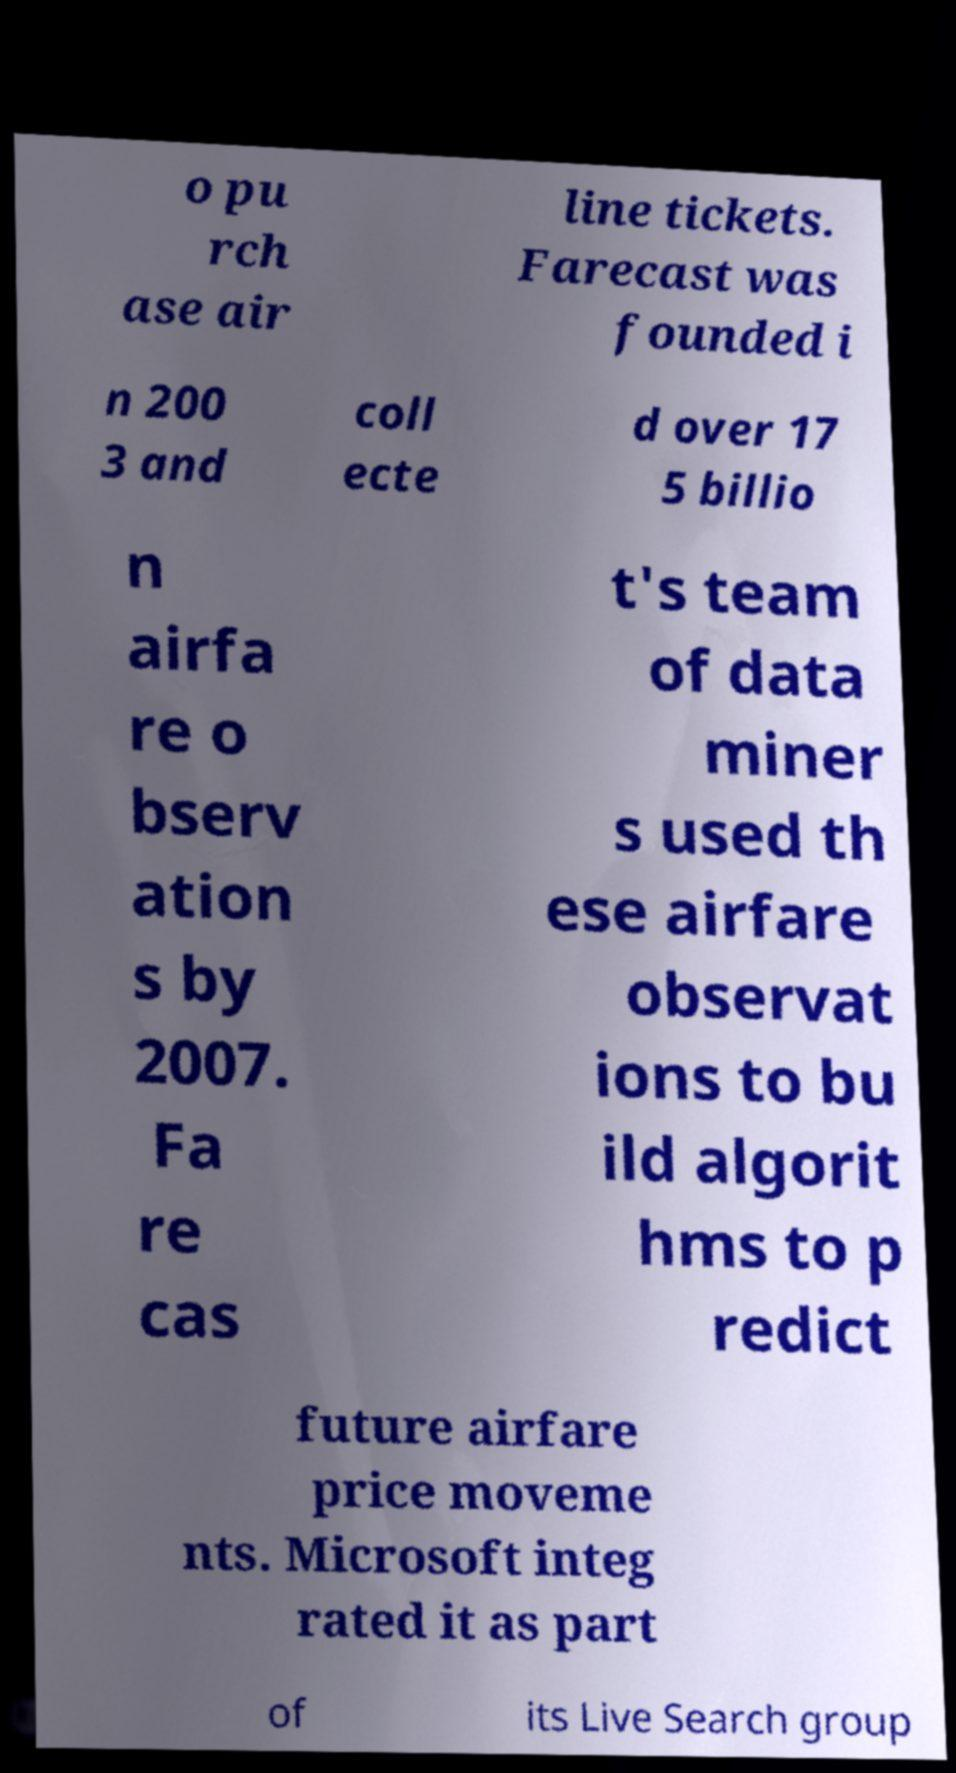For documentation purposes, I need the text within this image transcribed. Could you provide that? o pu rch ase air line tickets. Farecast was founded i n 200 3 and coll ecte d over 17 5 billio n airfa re o bserv ation s by 2007. Fa re cas t's team of data miner s used th ese airfare observat ions to bu ild algorit hms to p redict future airfare price moveme nts. Microsoft integ rated it as part of its Live Search group 